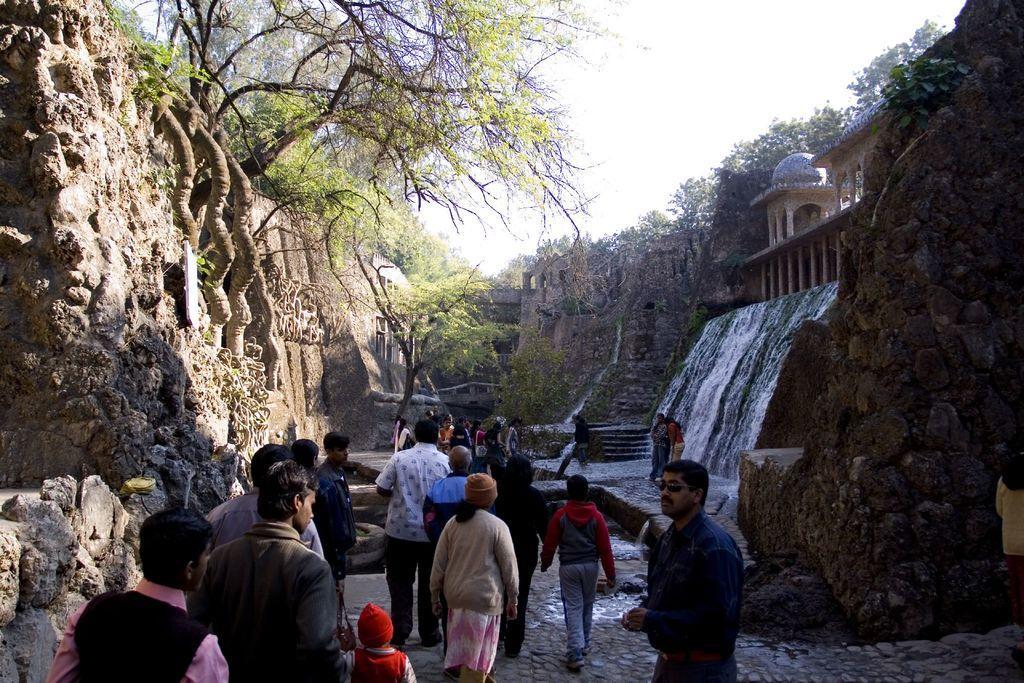Please provide a concise description of this image. In this image, there are groups of people standing. I can see trees, hills, a waterfall and an ancient architecture. In the background, there is the sky. 